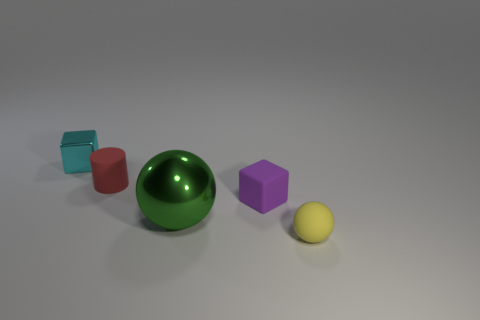Do the ball that is behind the yellow rubber sphere and the small block that is right of the tiny red rubber thing have the same material?
Keep it short and to the point. No. There is another thing that is the same shape as the yellow matte thing; what is its material?
Offer a terse response. Metal. Is the yellow thing made of the same material as the small purple cube?
Keep it short and to the point. Yes. There is a shiny thing in front of the metallic object behind the tiny cylinder; what is its color?
Ensure brevity in your answer.  Green. What size is the cube that is the same material as the tiny red object?
Ensure brevity in your answer.  Small. How many other small matte things have the same shape as the tiny purple object?
Give a very brief answer. 0. What number of things are things to the left of the tiny yellow rubber thing or metallic objects that are behind the cylinder?
Make the answer very short. 4. There is a block that is on the left side of the metal sphere; what number of small purple rubber cubes are to the left of it?
Keep it short and to the point. 0. There is a object in front of the large sphere; is it the same shape as the metal thing in front of the small cyan metal object?
Keep it short and to the point. Yes. Is there a tiny ball that has the same material as the large green ball?
Provide a short and direct response. No. 